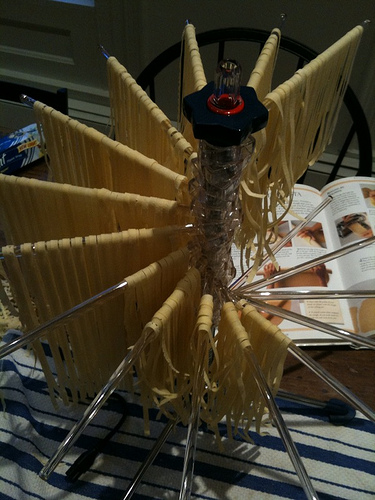<image>
Is the pasta in the book? No. The pasta is not contained within the book. These objects have a different spatial relationship. 